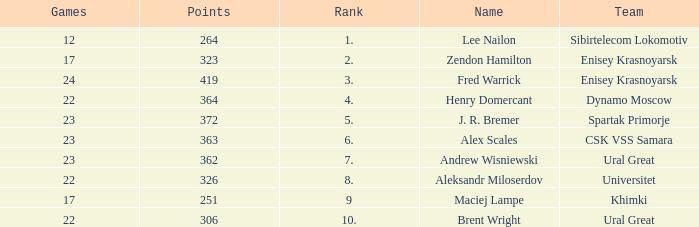What was the game with a rank higher than 2 and a name of zendon hamilton? None. 